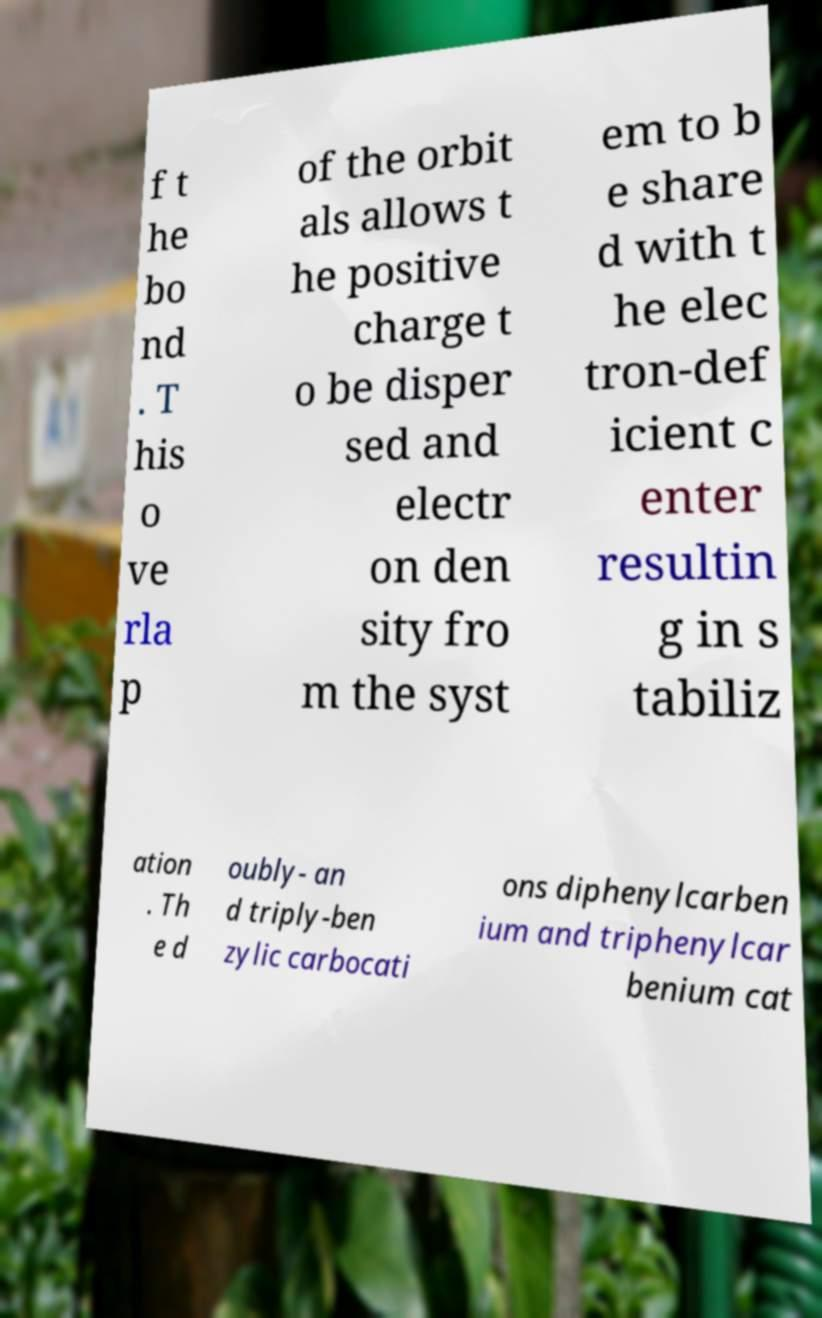Can you read and provide the text displayed in the image?This photo seems to have some interesting text. Can you extract and type it out for me? f t he bo nd . T his o ve rla p of the orbit als allows t he positive charge t o be disper sed and electr on den sity fro m the syst em to b e share d with t he elec tron-def icient c enter resultin g in s tabiliz ation . Th e d oubly- an d triply-ben zylic carbocati ons diphenylcarben ium and triphenylcar benium cat 